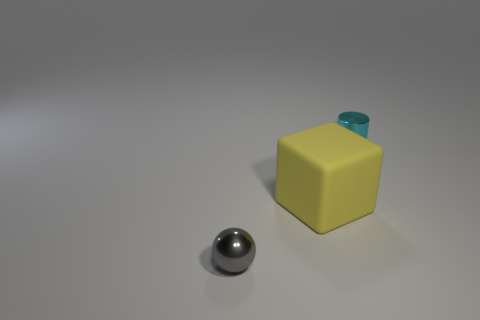Are there any other things that are the same shape as the gray object?
Ensure brevity in your answer.  No. There is a yellow rubber object that is to the right of the gray thing in front of the cyan cylinder; how big is it?
Keep it short and to the point. Large. What number of other things are there of the same size as the gray metal sphere?
Offer a terse response. 1. What number of small objects are behind the cyan metallic object?
Your response must be concise. 0. What is the size of the rubber object?
Keep it short and to the point. Large. Is the tiny object to the right of the tiny gray metallic thing made of the same material as the block that is in front of the cylinder?
Keep it short and to the point. No. There is a cylinder that is the same size as the gray metallic ball; what is its color?
Offer a terse response. Cyan. Are there any tiny cylinders that have the same material as the ball?
Provide a short and direct response. Yes. Are there fewer small metallic balls right of the tiny sphere than rubber cylinders?
Offer a terse response. No. Is the size of the metal object that is behind the ball the same as the small gray metal sphere?
Your answer should be compact. Yes. 